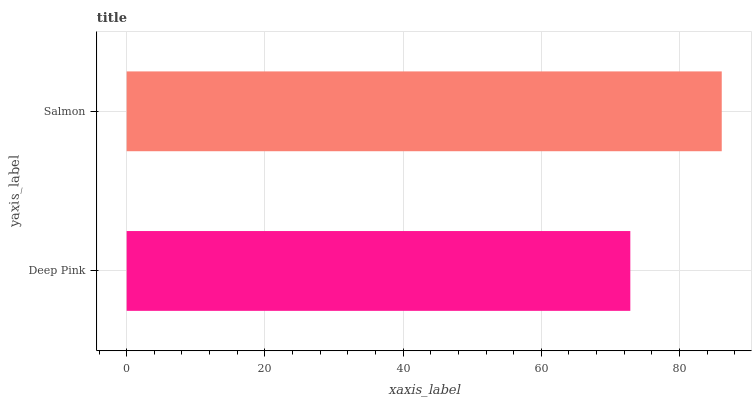Is Deep Pink the minimum?
Answer yes or no. Yes. Is Salmon the maximum?
Answer yes or no. Yes. Is Salmon the minimum?
Answer yes or no. No. Is Salmon greater than Deep Pink?
Answer yes or no. Yes. Is Deep Pink less than Salmon?
Answer yes or no. Yes. Is Deep Pink greater than Salmon?
Answer yes or no. No. Is Salmon less than Deep Pink?
Answer yes or no. No. Is Salmon the high median?
Answer yes or no. Yes. Is Deep Pink the low median?
Answer yes or no. Yes. Is Deep Pink the high median?
Answer yes or no. No. Is Salmon the low median?
Answer yes or no. No. 